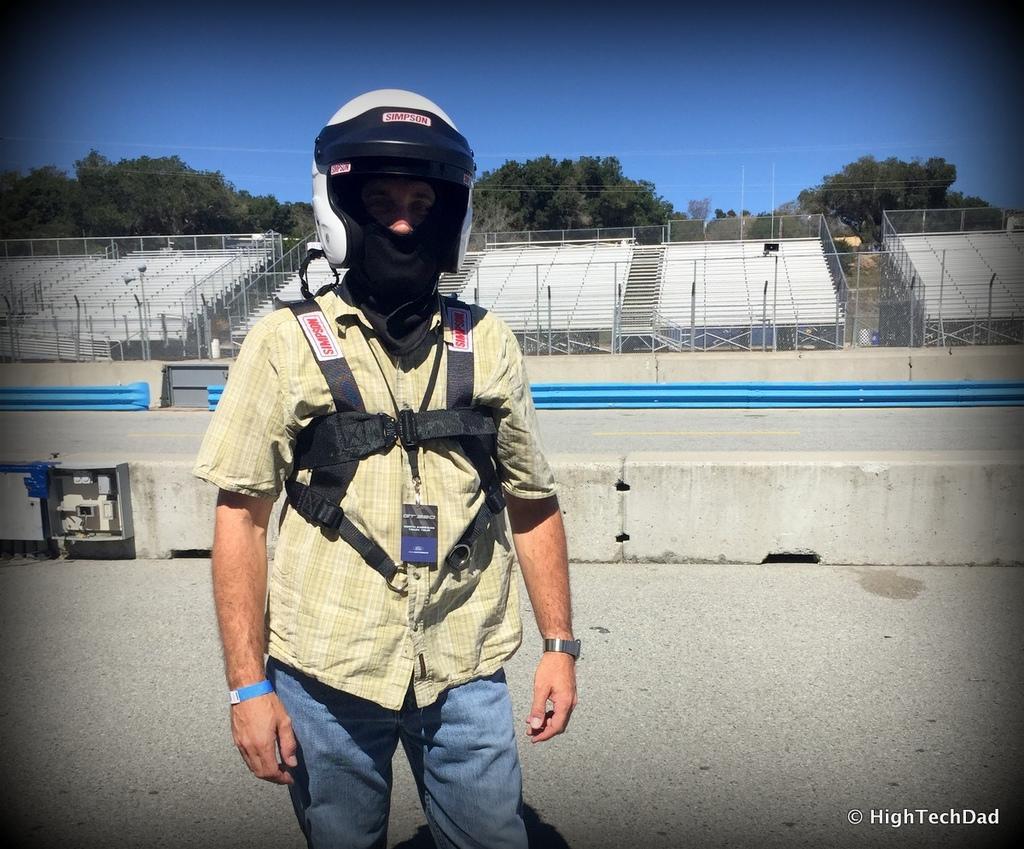Could you give a brief overview of what you see in this image? In this picture I can observe a man standing on the land. He is wearing white color helmet on his head. In the background there are trees and sky. 